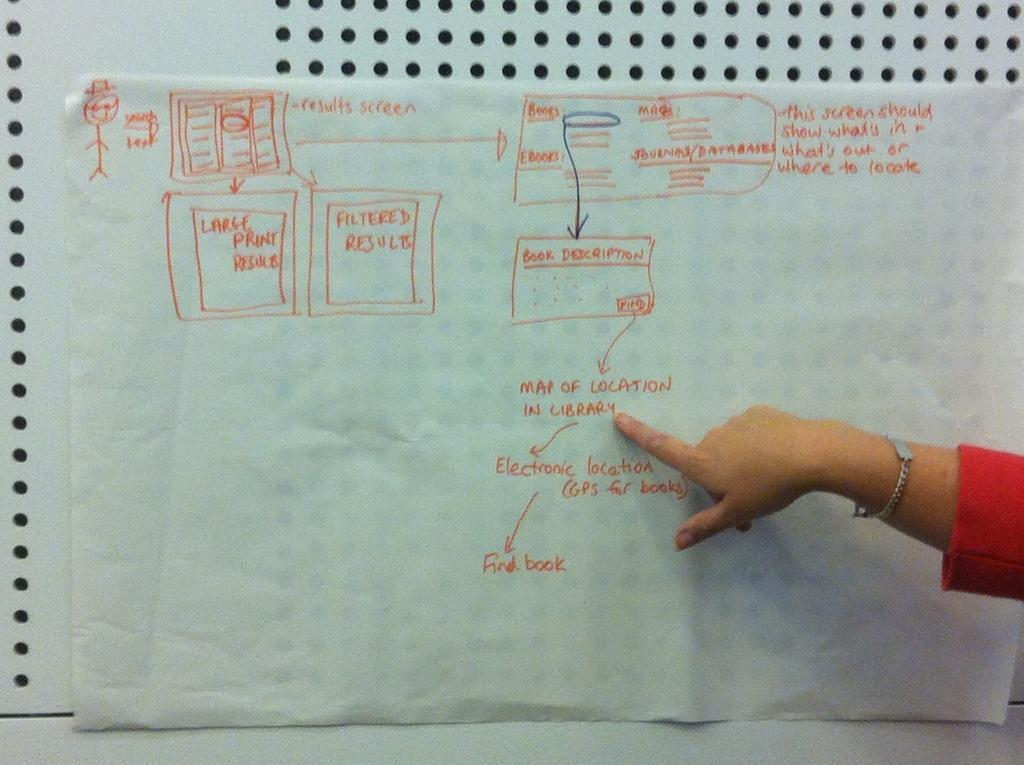Could you give a brief overview of what you see in this image? In this image on the right side, I can see a hand. I can see some text written on the paper. In the background, I can see the wall. 